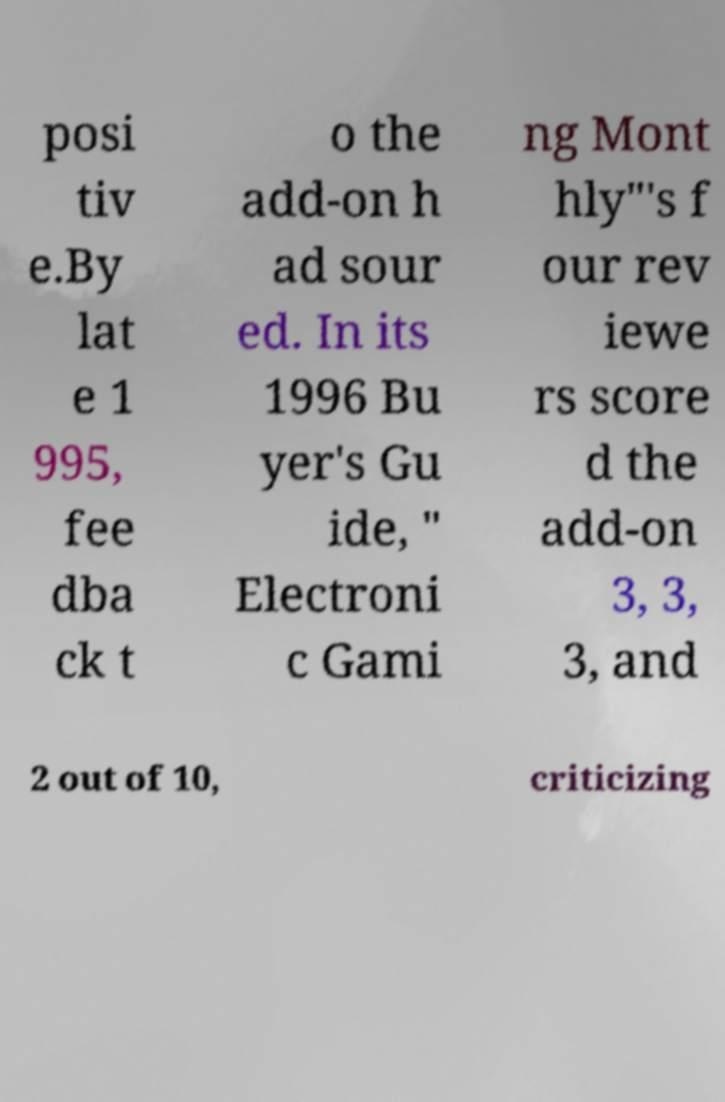Could you extract and type out the text from this image? posi tiv e.By lat e 1 995, fee dba ck t o the add-on h ad sour ed. In its 1996 Bu yer's Gu ide, " Electroni c Gami ng Mont hly"'s f our rev iewe rs score d the add-on 3, 3, 3, and 2 out of 10, criticizing 